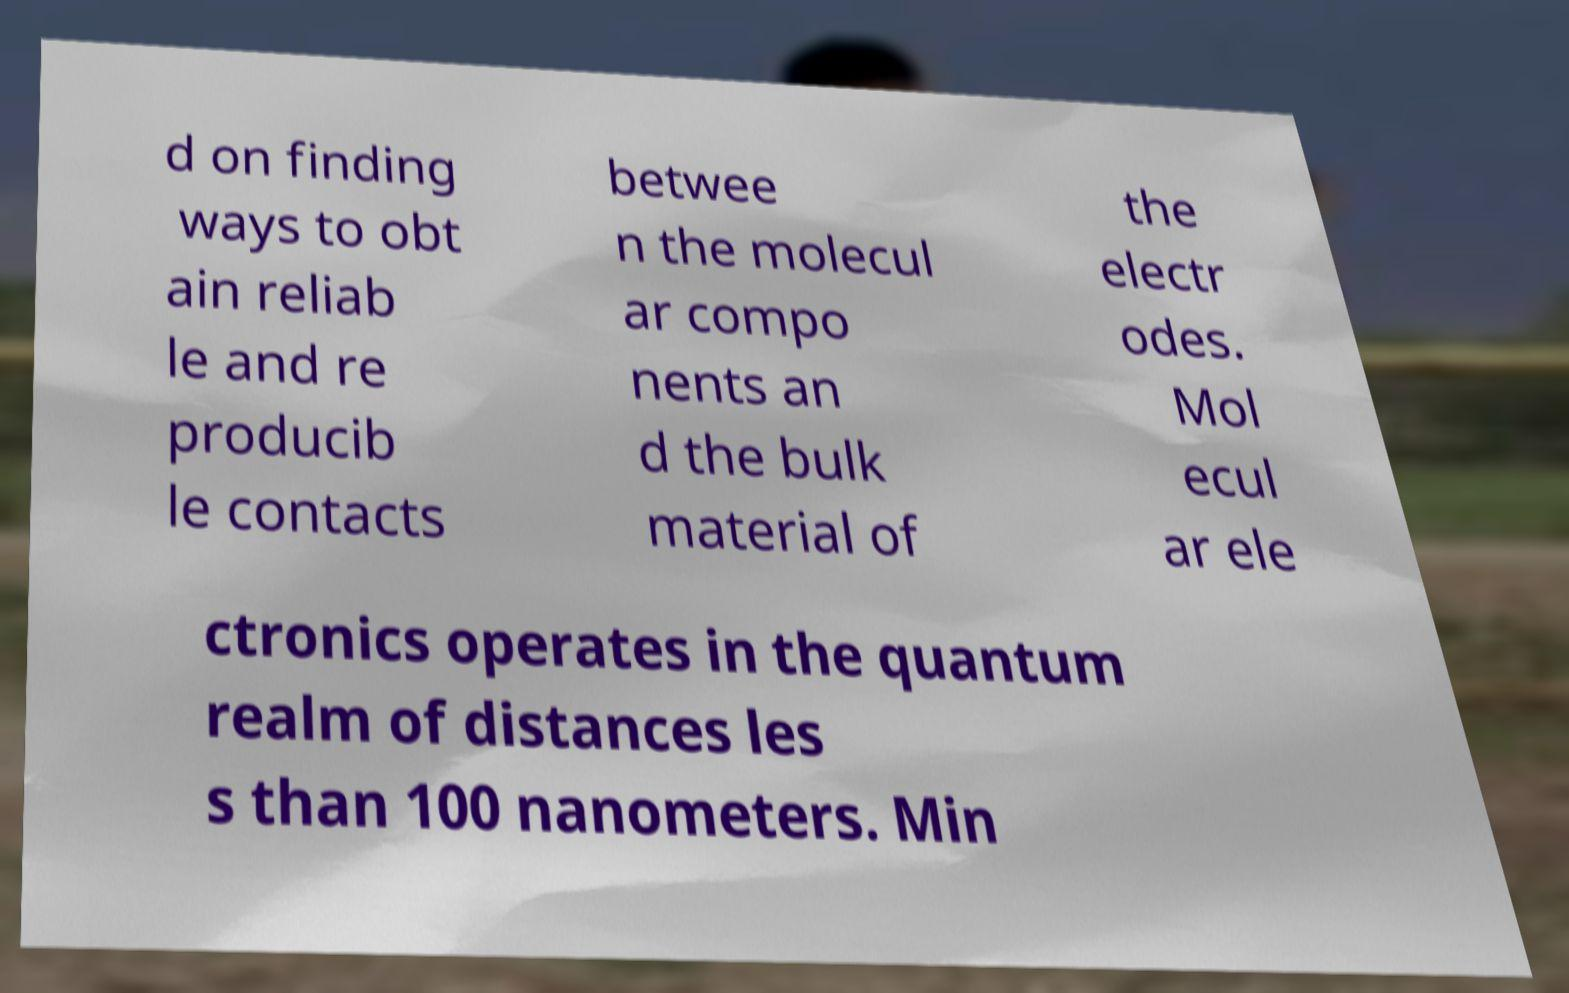Can you accurately transcribe the text from the provided image for me? d on finding ways to obt ain reliab le and re producib le contacts betwee n the molecul ar compo nents an d the bulk material of the electr odes. Mol ecul ar ele ctronics operates in the quantum realm of distances les s than 100 nanometers. Min 